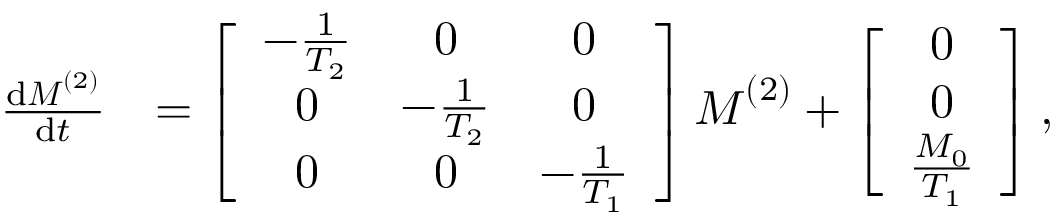Convert formula to latex. <formula><loc_0><loc_0><loc_500><loc_500>\begin{array} { r l } { \frac { d M ^ { ( 2 ) } } { d t } } & { = \left [ \begin{array} { c c c } { - \frac { 1 } { T _ { 2 } } } & { 0 } & { 0 } \\ { 0 } & { - \frac { 1 } { T _ { 2 } } } & { 0 } \\ { 0 } & { 0 } & { - \frac { 1 } { T _ { 1 } } } \end{array} \right ] M ^ { ( 2 ) } + \left [ \begin{array} { c } { 0 } \\ { 0 } \\ { \frac { M _ { 0 } } { T _ { 1 } } } \end{array} \right ] , } \end{array}</formula> 